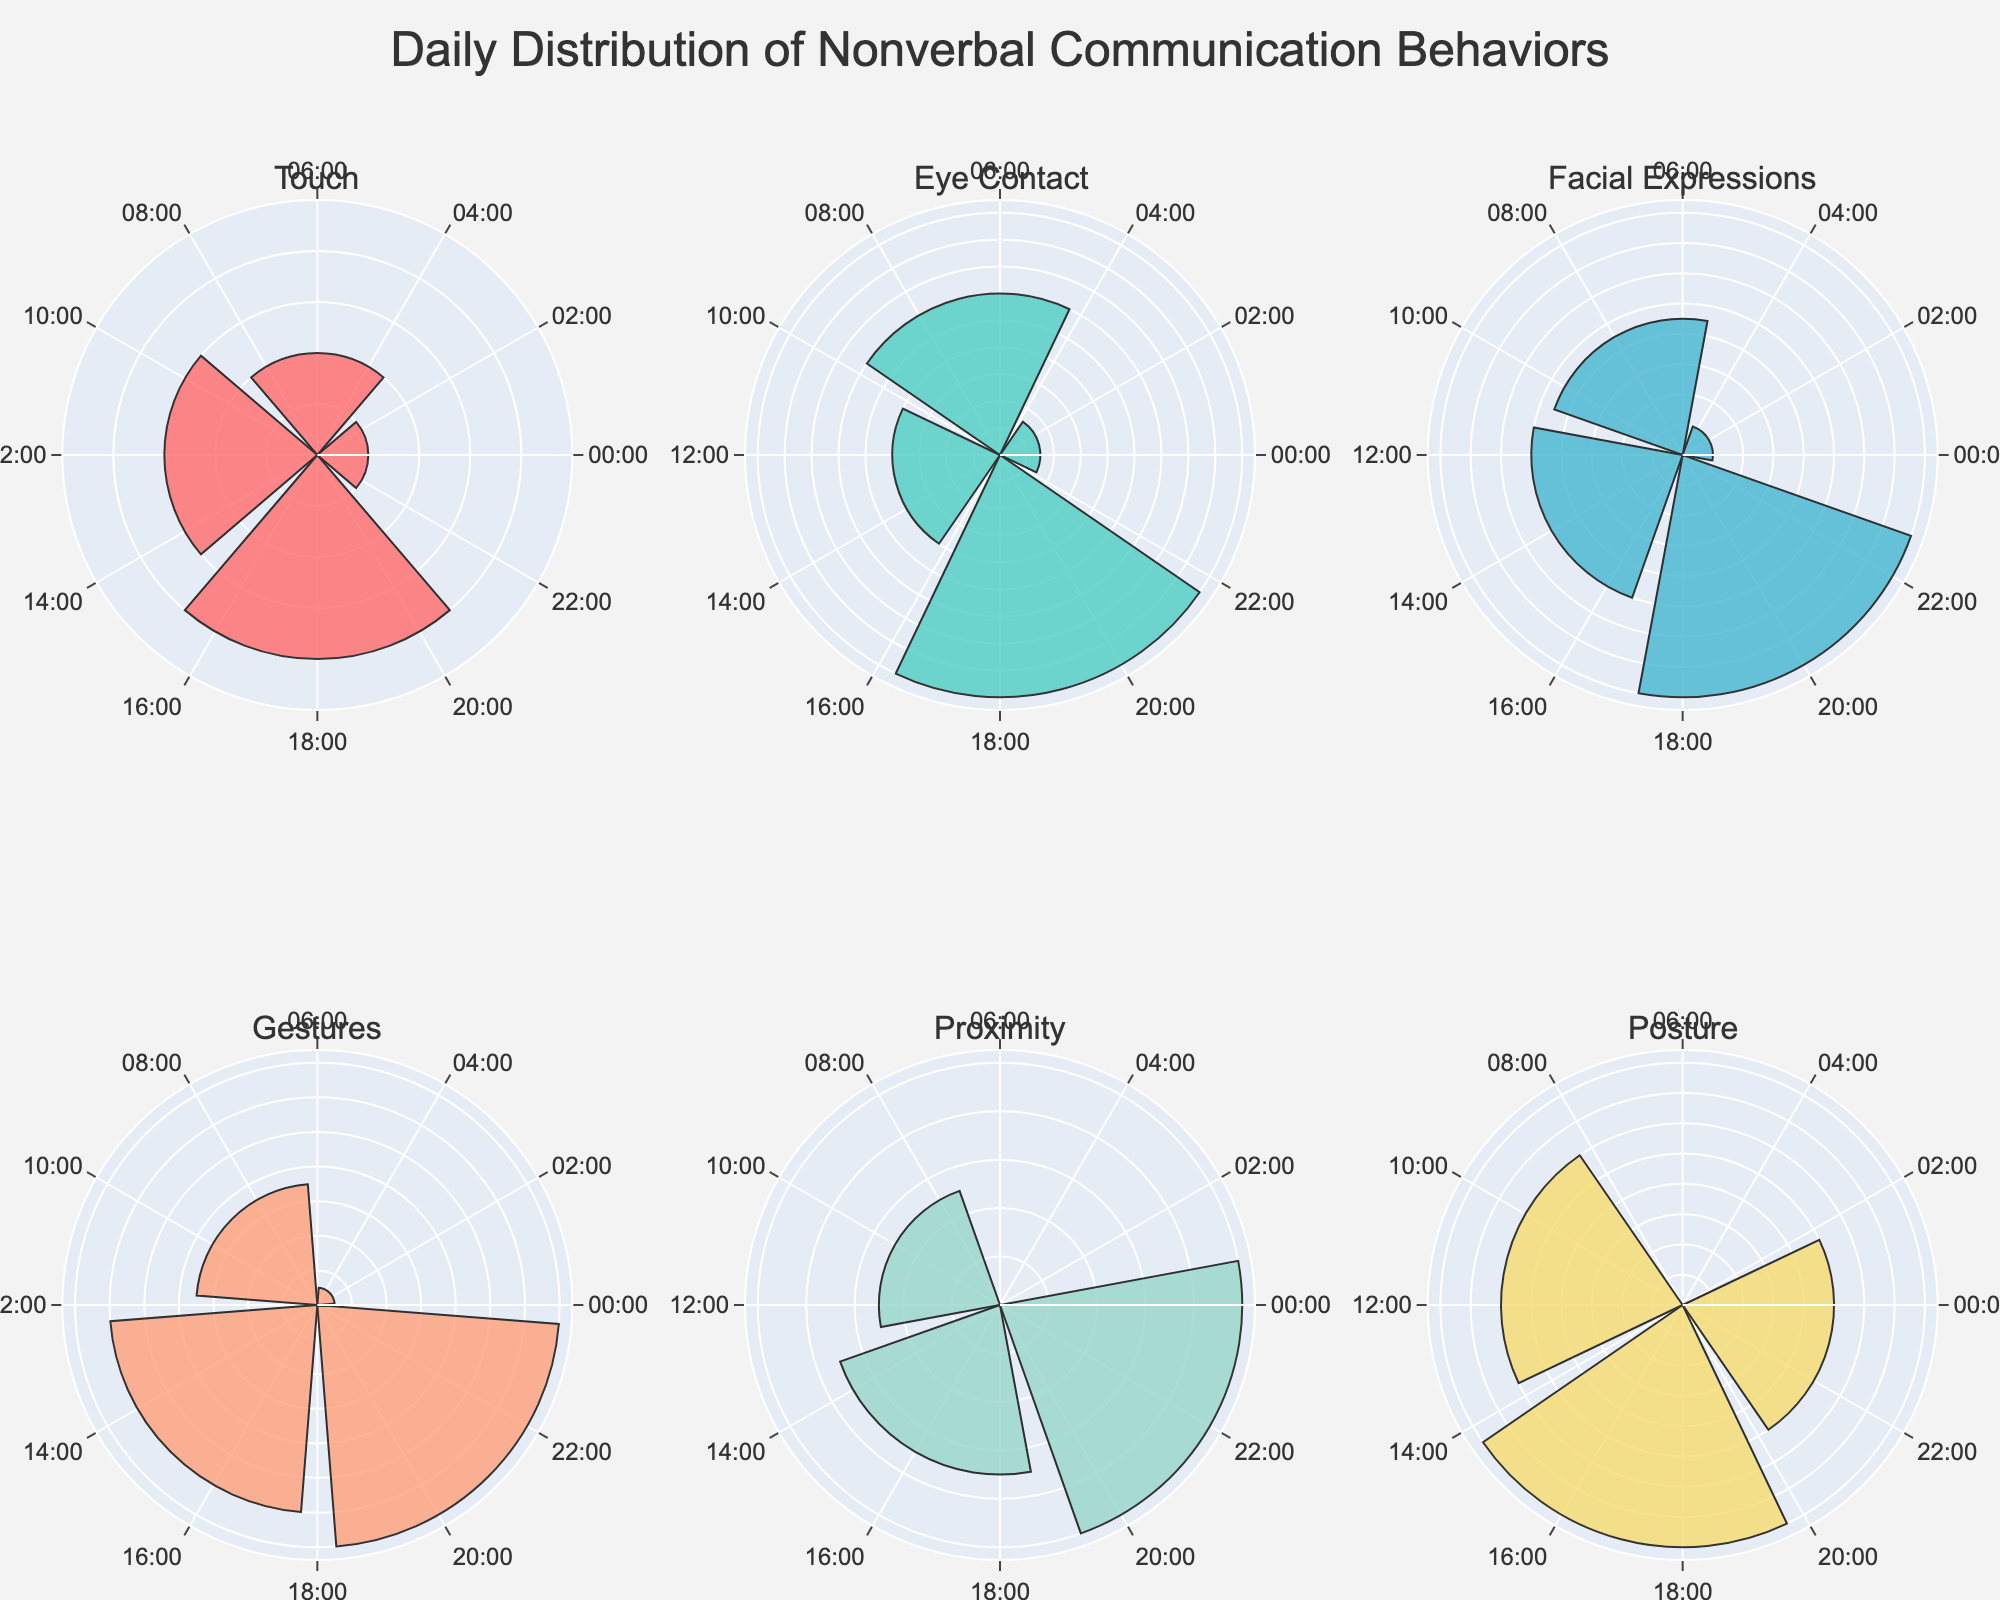What's the title of the figure? The title is located at the top center of the figure. It reads "Daily Distribution of Nonverbal Communication Behaviors".
Answer: Daily Distribution of Nonverbal Communication Behaviors Which behavior is represented by the chart in the bottom left? The bottom left chart corresponds to the third position in the second row. The subplot title indicates that the behavior represented is "Proximity".
Answer: Proximity How much time is spent on "Touch" at 18:00? Locate the "Touch" subplot and find the bar for 18:00. It shows a value of 20 minutes.
Answer: 20 minutes Which behavior has the highest peak time spent, and when? Compare the highest data points in each subplot. "Touch" at 18:00 has the highest peak, with 20 minutes.
Answer: Touch at 18:00 What is the total time spent on "Eye Contact" throughout the day? Sum the minutes for "Eye Contact" across all hours: 3 + 12 + 8 + 18 = 41.
Answer: 41 minutes During which time period is "Facial Expressions" most frequently observed? The peak value in the "Facial Expressions" subplot indicates the time. The highest bar is at 20:00, showing 16 minutes.
Answer: 20:00 Which behavior has the least time spent altogether? Compare the total time spent for each behavior by summing their data points. "Posture" has the least total time with 19 minutes (0 + 6 + 5 + 8 + 0).
Answer: Posture What is the average time spent on "Gestures" between 15:00 and 21:00? Locate and sum the minutes from 15:00 to 21:00 for "Gestures": 12 + 14 = 26. Divide by 2 (number of hours): 26/2 = 13 minutes.
Answer: 13 minutes How does the time spent on "Proximity" at 22:00 compare to "Posture" at the same time? Check the subplot for "Proximity" at 22:00, which shows 10 minutes, and "Posture" at 22:00, which shows 5 minutes. Compare the two values.
Answer: Proximity has 5 more minutes than Posture What's the pattern of "Touch" throughout the day? Observe the "Touch" subplot for patterns. Touch shows peaks at 6:00, 12:00, and 18:00, with no activity at early morning and late night.
Answer: Peaks at 6:00, 12:00, and 18:00 